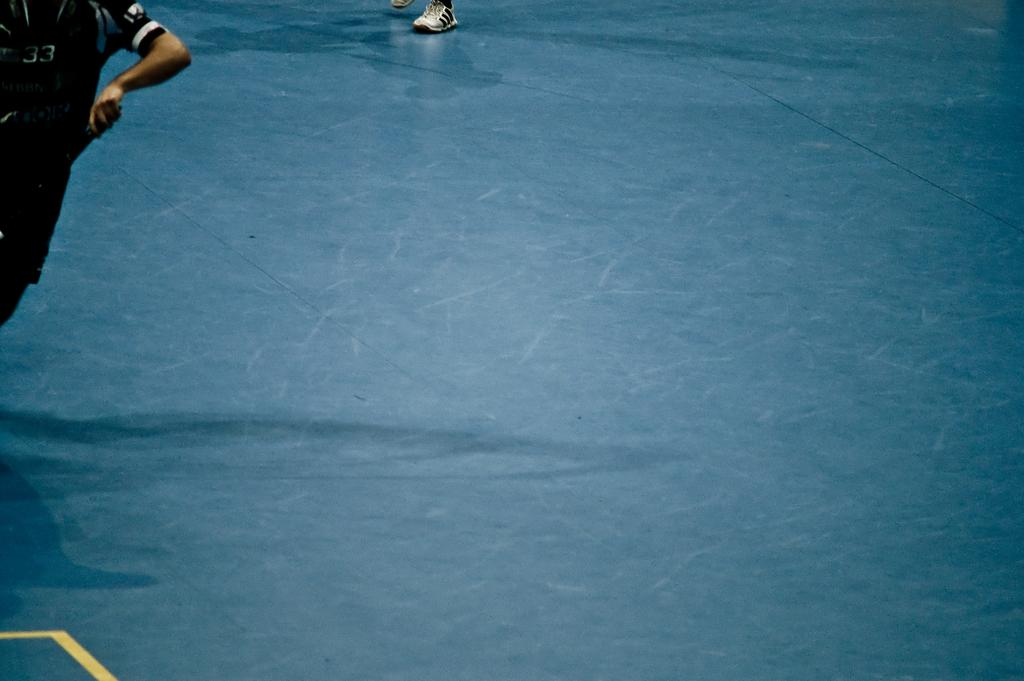What is located on the left side of the image? There is a player on the left side of the image. What part of a person can be seen in the image? The feet of a person are visible in the image. What type of surface is depicted in the image? The image depicts a ground. What color is the ground in the image? The ground is blue in color. What type of pencil is being used by the player in the image? There is no pencil visible in the image; it is a player on a blue ground. Can you hear any music playing in the image? There is no indication of music or any sound in the image. 